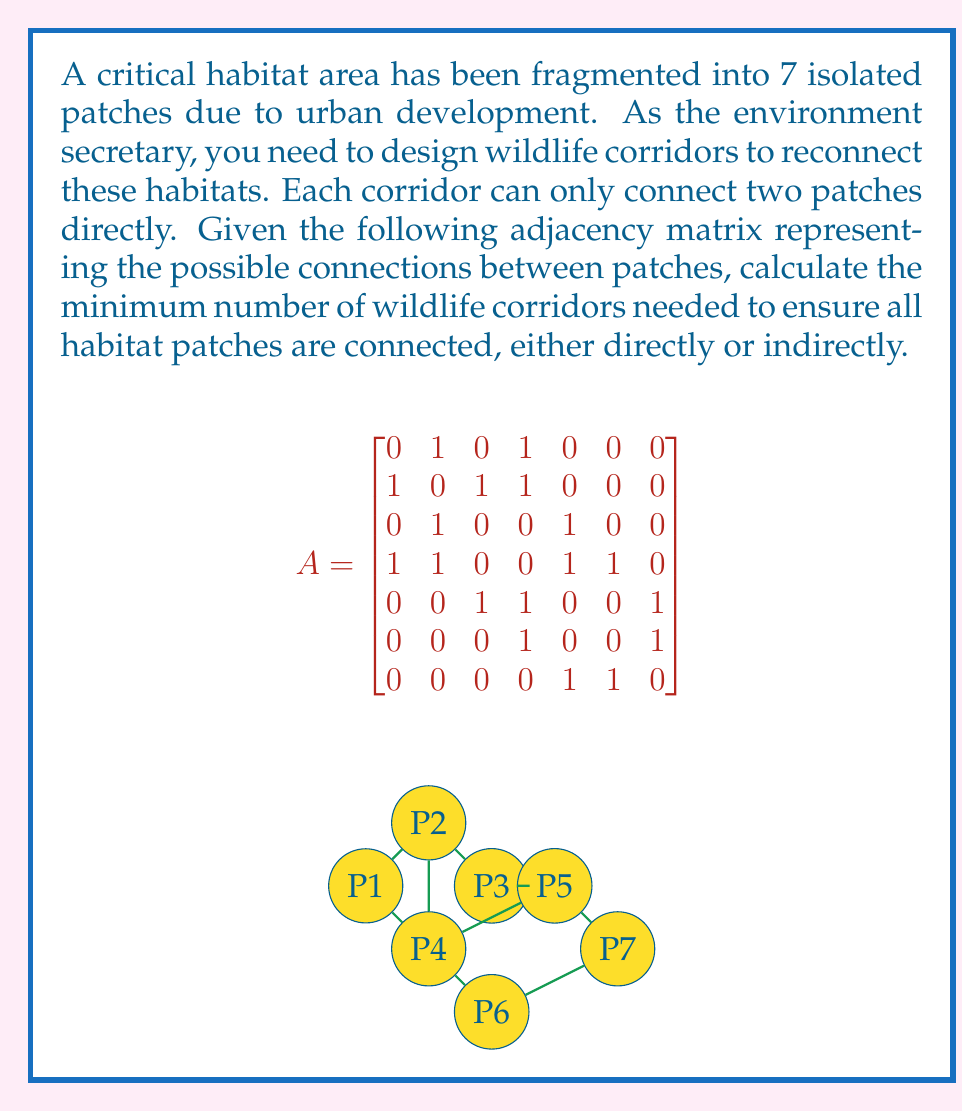Provide a solution to this math problem. To solve this problem, we can use graph theory concepts, specifically the idea of a minimum spanning tree (MST).

1) First, we recognize that the adjacency matrix represents an undirected graph where the habitat patches are vertices and the potential corridors are edges.

2) The minimum number of corridors needed to connect all patches is equal to the number of edges in a minimum spanning tree of this graph.

3) For a graph with $n$ vertices, any spanning tree will have exactly $n-1$ edges.

4) In this case, we have 7 habitat patches (vertices), so the minimum number of corridors (edges) needed is:

   $n - 1 = 7 - 1 = 6$

5) We can verify this by constructing a spanning tree:
   - Start with any vertex, say P1
   - Connect P1 to P2
   - Connect P2 to P3
   - Connect P1 to P4
   - Connect P4 to P5
   - Connect P4 to P6
   - Connect P5 to P7

   This creates a tree that spans all vertices using 6 edges.

6) Note that while there may be multiple possible spanning trees, they will all have the same number of edges (6 in this case).

This solution ensures that all habitat patches are connected either directly or indirectly, using the minimum number of corridors possible.
Answer: The minimum number of wildlife corridors needed is 6. 